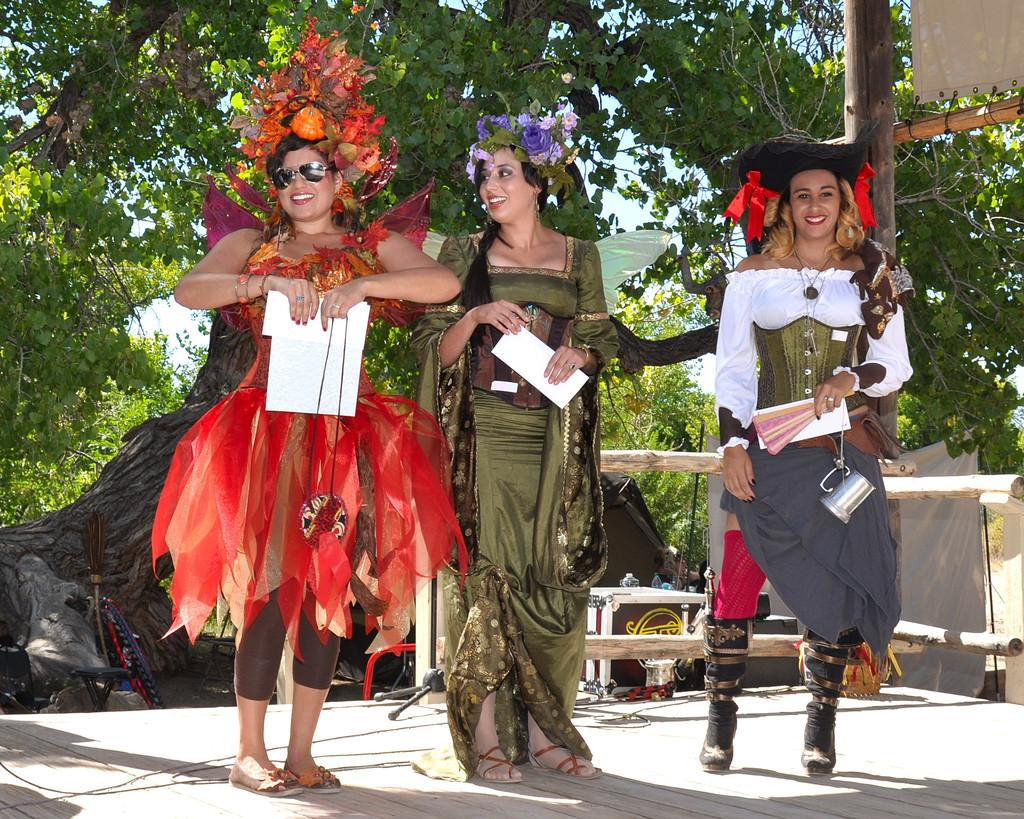How many women are in the image? There are three women in the image. Where are the women located in the image? The women are standing on a stage in the image. What are the women holding in the image? The women are holding papers in the image. What type of objects can be seen in the image besides the women? There are wooden poles, trees, a broom, objects on a table, and a cloth visible in the image. What is visible in the background of the image? The sky is visible in the image. What type of bubble is floating near the women in the image? There is no bubble present in the image. What type of soda is being served on the table in the image? There is no soda present in the image; only objects on a table are visible. 